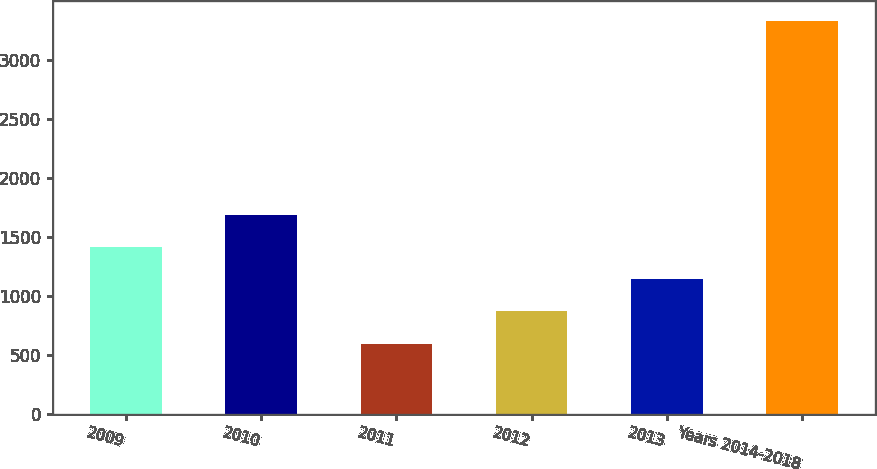Convert chart. <chart><loc_0><loc_0><loc_500><loc_500><bar_chart><fcel>2009<fcel>2010<fcel>2011<fcel>2012<fcel>2013<fcel>Years 2014-2018<nl><fcel>1417.8<fcel>1691.4<fcel>597<fcel>870.6<fcel>1144.2<fcel>3333<nl></chart> 